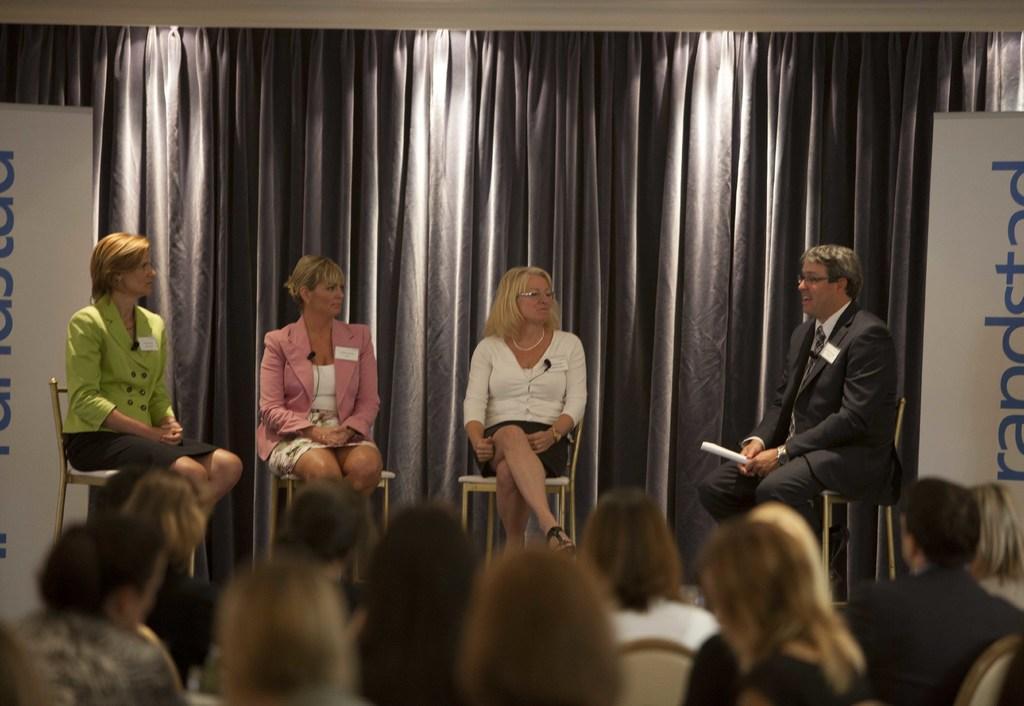In one or two sentences, can you explain what this image depicts? Here we can see four persons are sitting on the chairs and he is holding a paper with his hands. There are few people and banners. In the background there are curtains. 